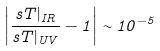Convert formula to latex. <formula><loc_0><loc_0><loc_500><loc_500>\left | \frac { s T | _ { I R } } { s T | _ { U V } } - 1 \right | \sim 1 0 ^ { - 5 }</formula> 